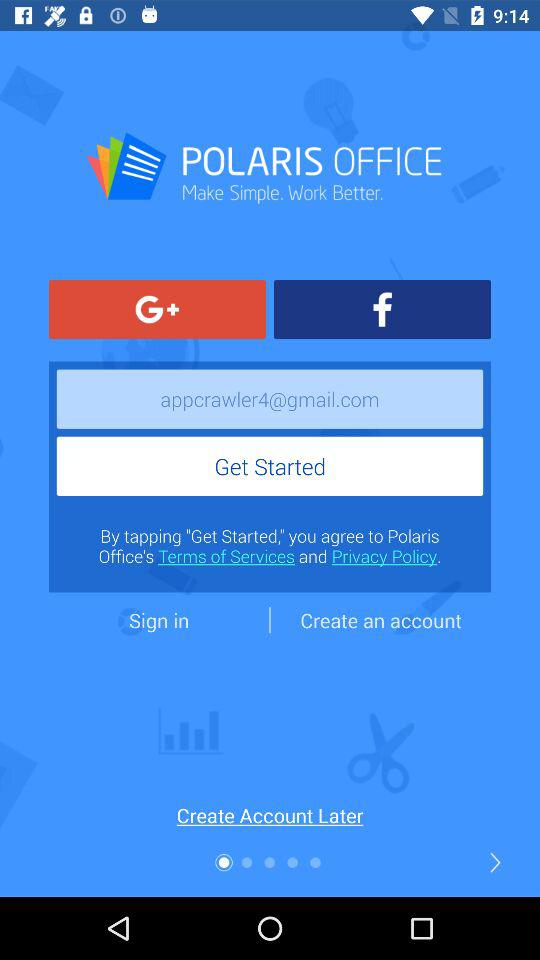Has the user agreed to the terms of service and privacy policy?
When the provided information is insufficient, respond with <no answer>. <no answer> 